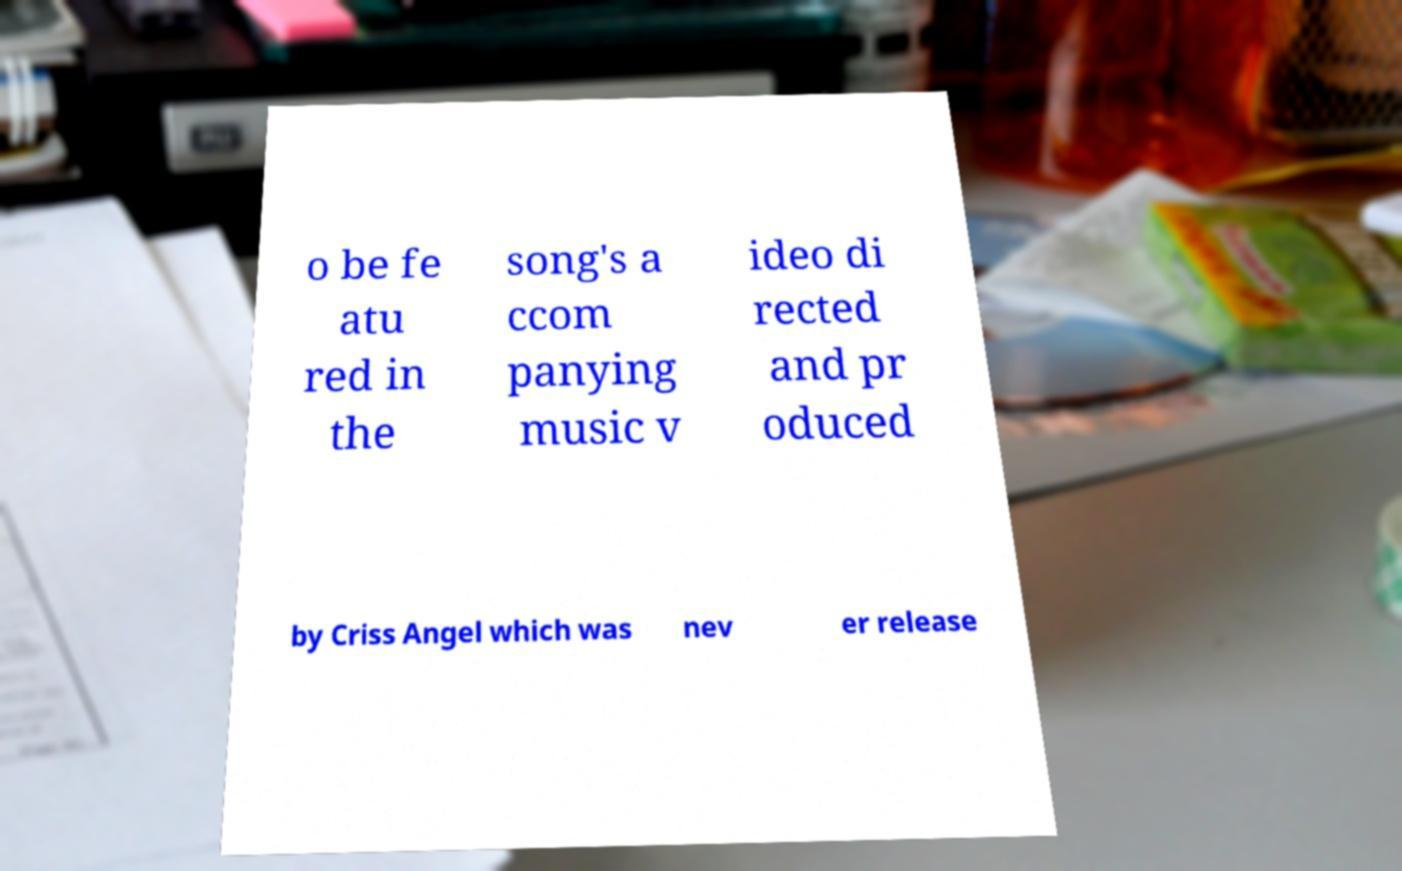Can you read and provide the text displayed in the image?This photo seems to have some interesting text. Can you extract and type it out for me? o be fe atu red in the song's a ccom panying music v ideo di rected and pr oduced by Criss Angel which was nev er release 